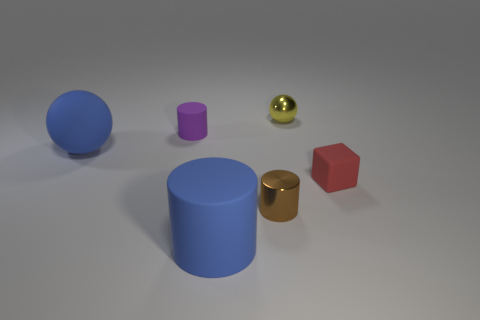Is the size of the blue matte thing that is behind the small red matte object the same as the metal thing that is in front of the tiny yellow shiny thing?
Give a very brief answer. No. How many other things are there of the same material as the small purple cylinder?
Make the answer very short. 3. Are there more purple cylinders in front of the small metal cylinder than metallic cylinders that are to the left of the large ball?
Give a very brief answer. No. There is a tiny cylinder that is in front of the small rubber cube; what material is it?
Provide a succinct answer. Metal. Is the yellow object the same shape as the purple rubber object?
Your response must be concise. No. Is there any other thing of the same color as the big matte sphere?
Keep it short and to the point. Yes. What is the color of the other big thing that is the same shape as the brown metal object?
Your answer should be very brief. Blue. Is the number of tiny yellow shiny spheres left of the small purple rubber cylinder greater than the number of small gray balls?
Your answer should be very brief. No. There is a matte cylinder in front of the tiny metallic cylinder; what is its color?
Offer a terse response. Blue. Do the red rubber object and the blue ball have the same size?
Your response must be concise. No. 